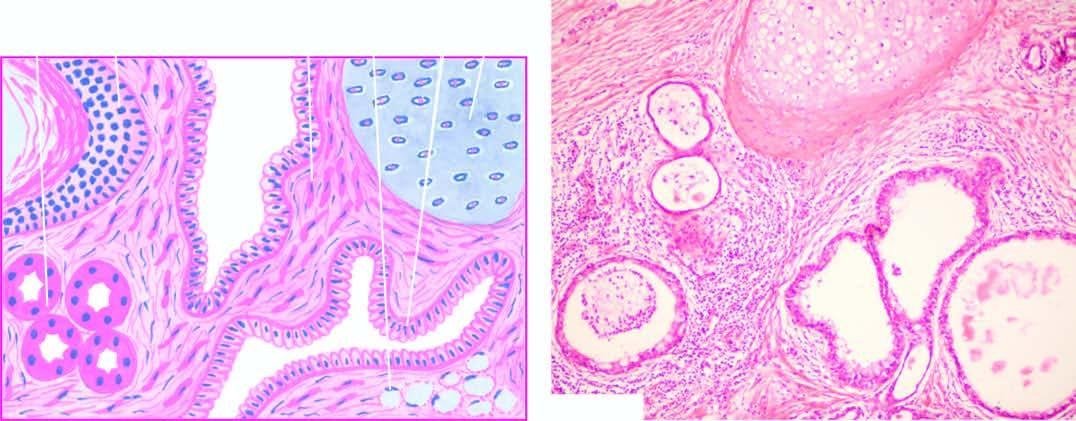re etastatic carcinomatous deposits in the also seen?
Answer the question using a single word or phrase. No 